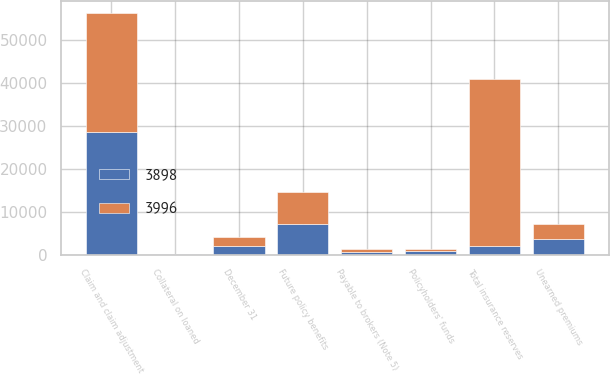Convert chart to OTSL. <chart><loc_0><loc_0><loc_500><loc_500><stacked_bar_chart><ecel><fcel>December 31<fcel>Claim and claim adjustment<fcel>Future policy benefits<fcel>Unearned premiums<fcel>Policyholders' funds<fcel>Total insurance reserves<fcel>Payable to brokers (Note 5)<fcel>Collateral on loaned<nl><fcel>3996<fcel>2008<fcel>27593<fcel>7529<fcel>3405<fcel>243<fcel>38770<fcel>679<fcel>6<nl><fcel>3898<fcel>2007<fcel>28588<fcel>7106<fcel>3597<fcel>930<fcel>2008<fcel>580<fcel>63<nl></chart> 